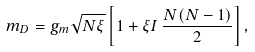<formula> <loc_0><loc_0><loc_500><loc_500>m _ { D } = g _ { m } \sqrt { N \xi } \left [ 1 + \xi I \, \frac { N ( N - 1 ) } { 2 } \right ] ,</formula> 